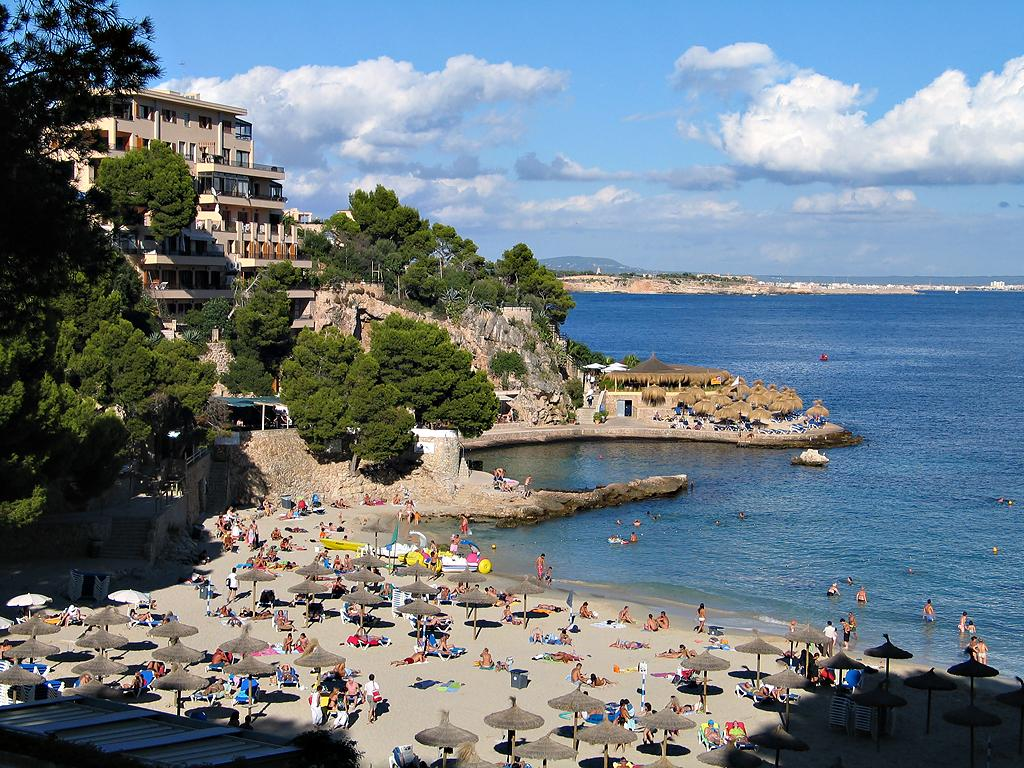How many people are in the image? There are people in the image, but the exact number is not specified. What surface are the people on? The people are on the sand in the image. What type of shelter is visible in the image? There are umbrellas in the image. What type of structure is present in the image? There is a wall in the image. What type of vegetation is present in the image? There are trees in the image. What type of buildings are visible in the image? There are houses in the image. What natural feature is visible in the image? There is water visible in the image. How would you describe the sky in the image? The sky is blue with clouds in the background. Can you see an airplane flying over the water in the image? There is no airplane visible in the image. What type of border is present between the sand and the water in the image? There is no border present between the sand and the water in the image; it is a natural transition. 